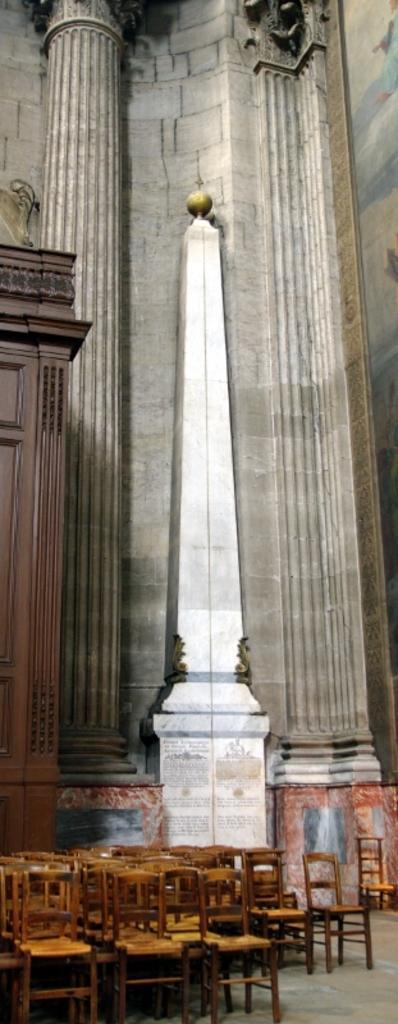Please provide a concise description of this image. This is a part of a building. At the bottom there are many empty chairs on the floor. In the middle of the image there is an obelisk. On the left side there is a cupboard. In the background there is a pillar and a wall. 